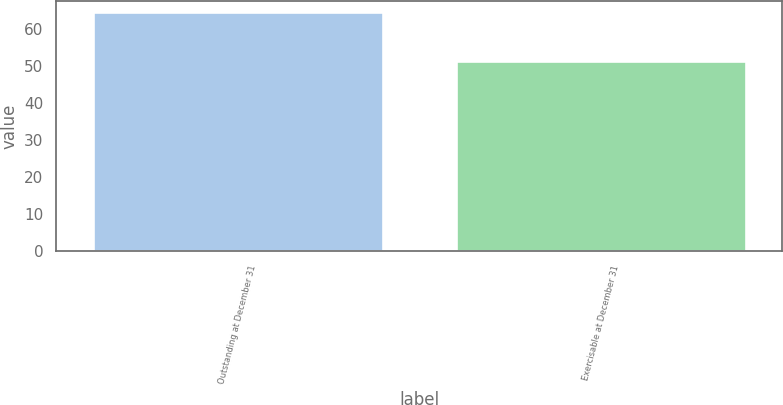Convert chart to OTSL. <chart><loc_0><loc_0><loc_500><loc_500><bar_chart><fcel>Outstanding at December 31<fcel>Exercisable at December 31<nl><fcel>64.5<fcel>51.3<nl></chart> 